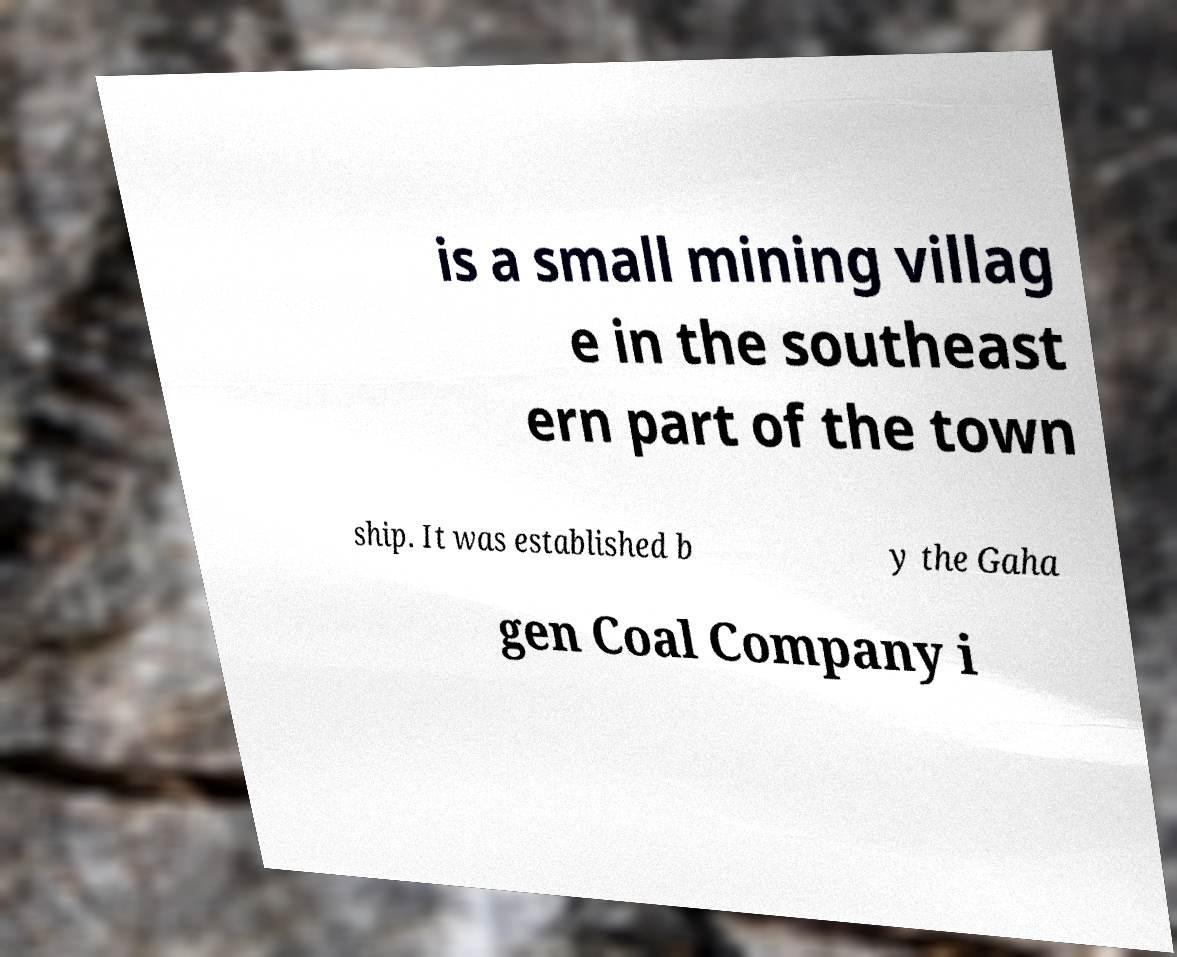Can you accurately transcribe the text from the provided image for me? is a small mining villag e in the southeast ern part of the town ship. It was established b y the Gaha gen Coal Company i 